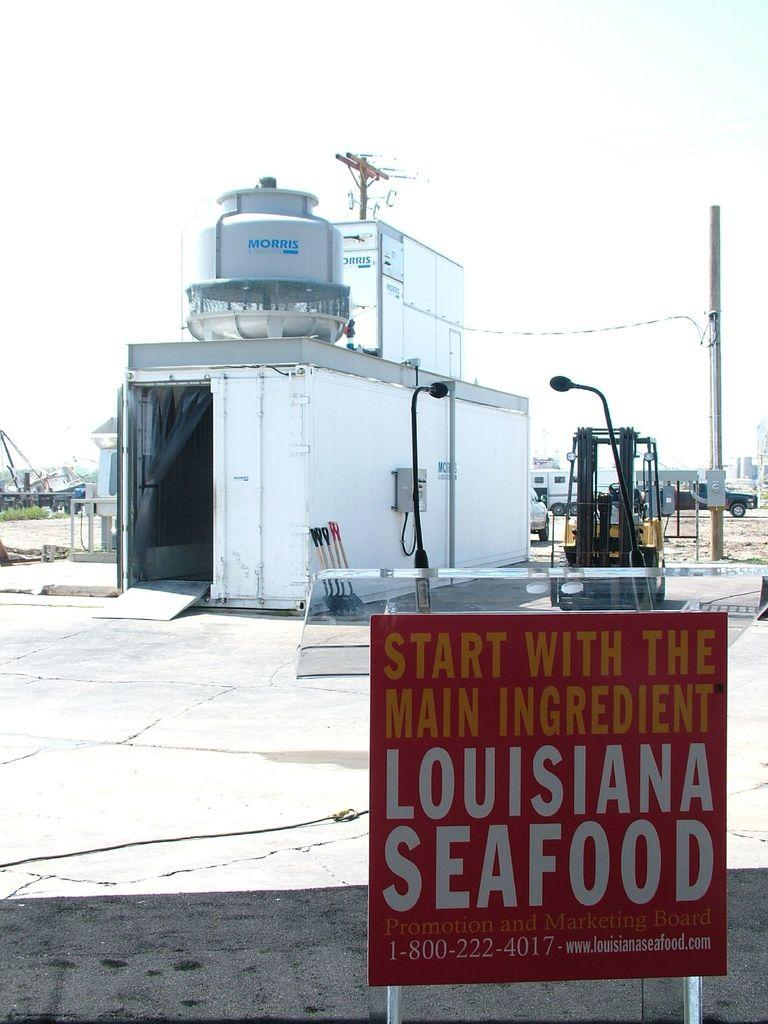<image>
Write a terse but informative summary of the picture. Red sign that says Louisiana Seafood in front of some containers. 